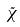<formula> <loc_0><loc_0><loc_500><loc_500>\tilde { \chi }</formula> 